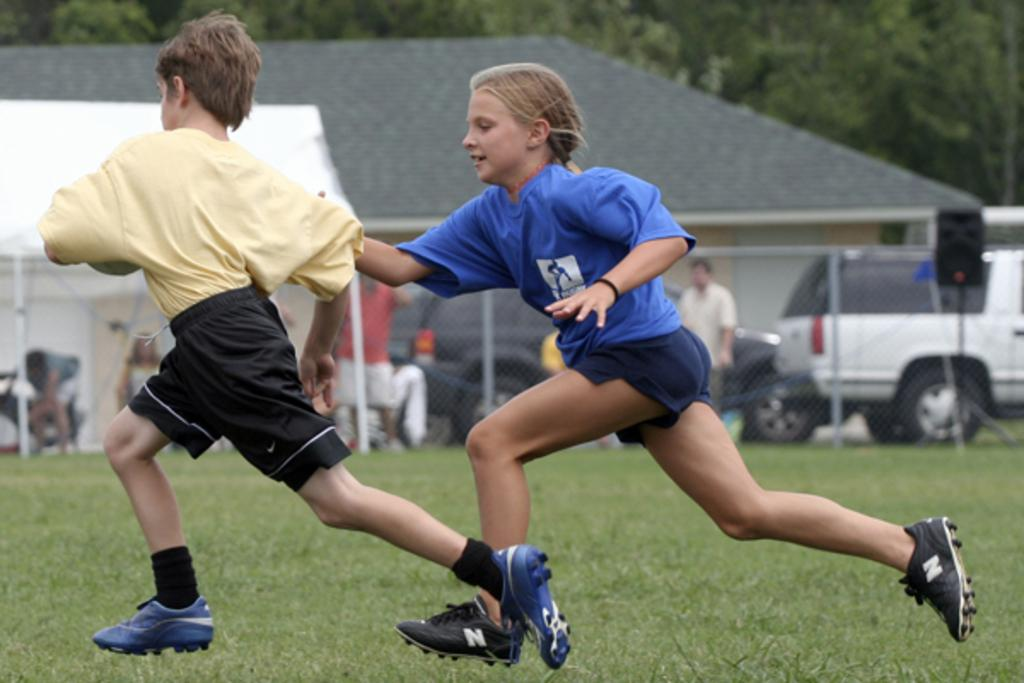What are the kids in the image doing? The kids in the image are running. What type of surface can be seen beneath the kids? There is grass visible in the image. What can be seen in the background of the image? In the background of the image, there is a mesh, vehicles, people, a tent, a house, and trees. What type of arm can be seen holding a glass in the image? There is no arm or glass present in the image. What sound does the bell make in the image? There is no bell present in the image. 